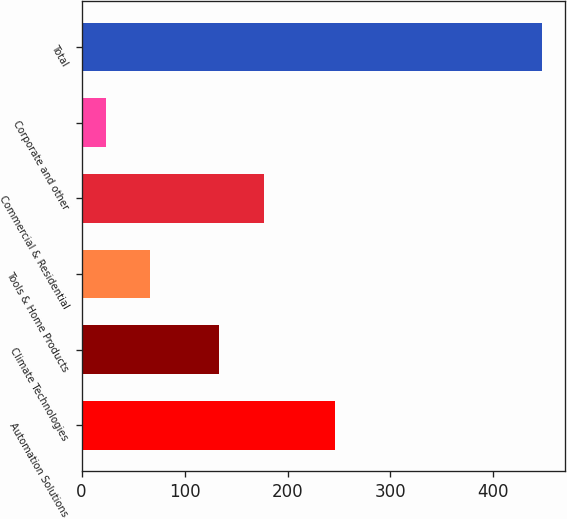Convert chart. <chart><loc_0><loc_0><loc_500><loc_500><bar_chart><fcel>Automation Solutions<fcel>Climate Technologies<fcel>Tools & Home Products<fcel>Commercial & Residential<fcel>Corporate and other<fcel>Total<nl><fcel>246<fcel>133<fcel>66.3<fcel>177<fcel>24<fcel>447<nl></chart> 